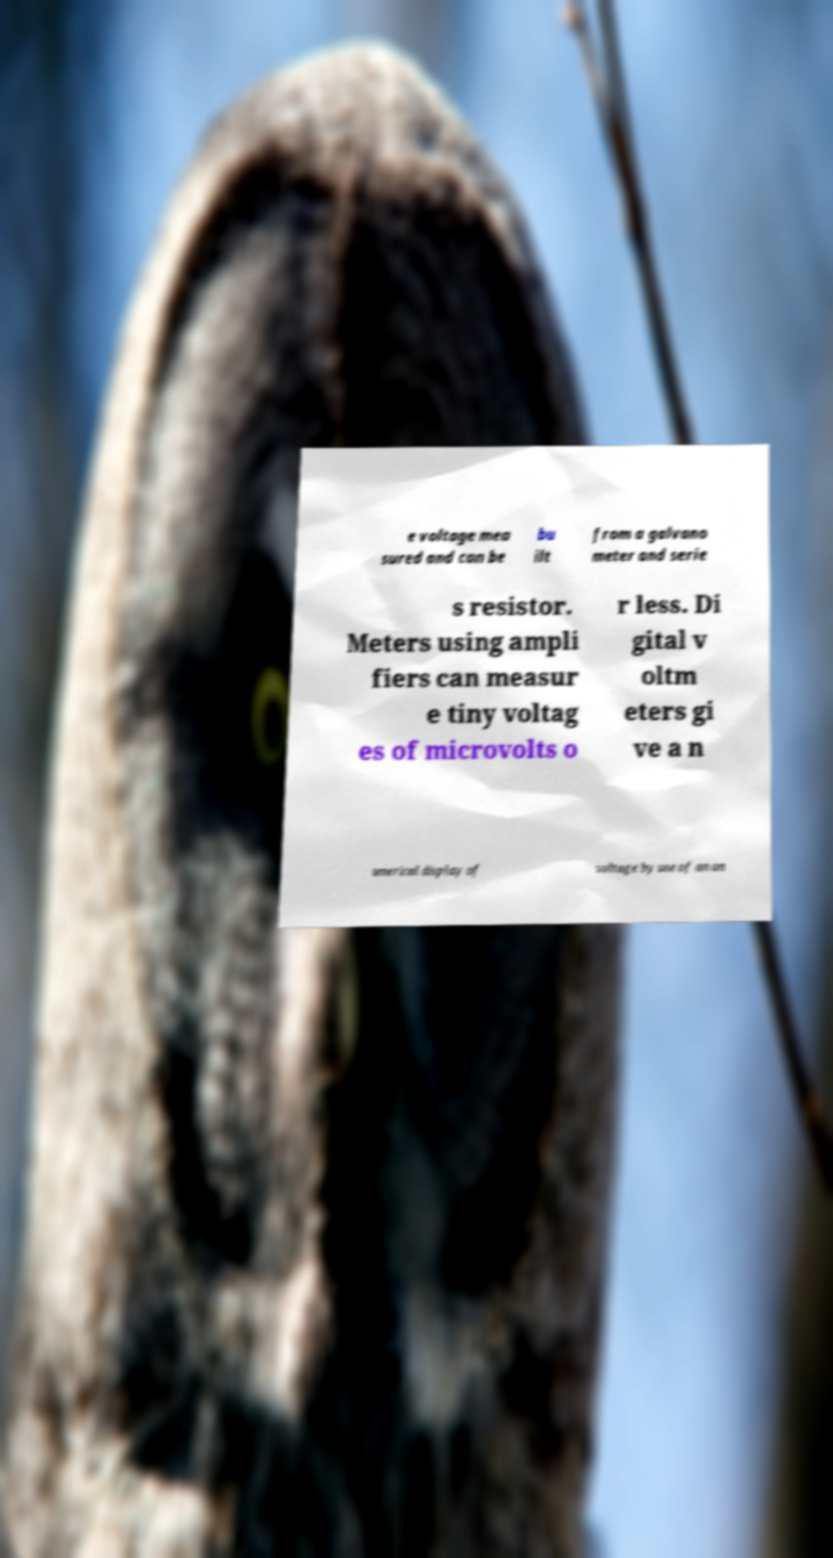Can you accurately transcribe the text from the provided image for me? e voltage mea sured and can be bu ilt from a galvano meter and serie s resistor. Meters using ampli fiers can measur e tiny voltag es of microvolts o r less. Di gital v oltm eters gi ve a n umerical display of voltage by use of an an 